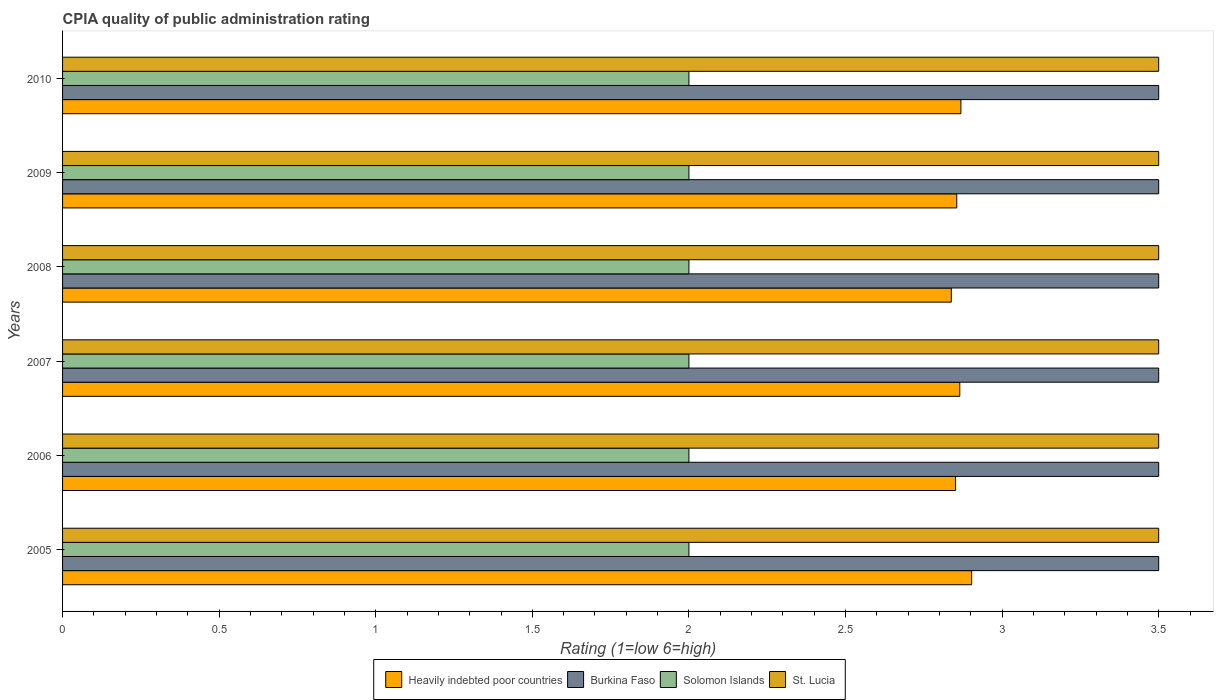How many different coloured bars are there?
Keep it short and to the point. 4. Are the number of bars on each tick of the Y-axis equal?
Keep it short and to the point. Yes. How many bars are there on the 5th tick from the bottom?
Offer a terse response. 4. Across all years, what is the maximum CPIA rating in Burkina Faso?
Provide a short and direct response. 3.5. Across all years, what is the minimum CPIA rating in Heavily indebted poor countries?
Keep it short and to the point. 2.84. What is the total CPIA rating in Heavily indebted poor countries in the graph?
Provide a short and direct response. 17.18. In the year 2010, what is the difference between the CPIA rating in Heavily indebted poor countries and CPIA rating in St. Lucia?
Your answer should be very brief. -0.63. What is the ratio of the CPIA rating in Burkina Faso in 2008 to that in 2009?
Your answer should be compact. 1. Is the CPIA rating in St. Lucia in 2007 less than that in 2010?
Ensure brevity in your answer.  No. What is the difference between the highest and the second highest CPIA rating in St. Lucia?
Keep it short and to the point. 0. What is the difference between the highest and the lowest CPIA rating in Heavily indebted poor countries?
Your answer should be compact. 0.06. Is it the case that in every year, the sum of the CPIA rating in Heavily indebted poor countries and CPIA rating in St. Lucia is greater than the sum of CPIA rating in Solomon Islands and CPIA rating in Burkina Faso?
Your answer should be compact. No. What does the 4th bar from the top in 2005 represents?
Provide a succinct answer. Heavily indebted poor countries. What does the 4th bar from the bottom in 2010 represents?
Keep it short and to the point. St. Lucia. Are all the bars in the graph horizontal?
Make the answer very short. Yes. How many years are there in the graph?
Give a very brief answer. 6. Does the graph contain grids?
Give a very brief answer. No. Where does the legend appear in the graph?
Make the answer very short. Bottom center. What is the title of the graph?
Provide a short and direct response. CPIA quality of public administration rating. What is the label or title of the X-axis?
Your answer should be very brief. Rating (1=low 6=high). What is the Rating (1=low 6=high) of Heavily indebted poor countries in 2005?
Give a very brief answer. 2.9. What is the Rating (1=low 6=high) of Burkina Faso in 2005?
Offer a very short reply. 3.5. What is the Rating (1=low 6=high) in St. Lucia in 2005?
Provide a succinct answer. 3.5. What is the Rating (1=low 6=high) of Heavily indebted poor countries in 2006?
Your answer should be very brief. 2.85. What is the Rating (1=low 6=high) in Solomon Islands in 2006?
Your answer should be compact. 2. What is the Rating (1=low 6=high) in St. Lucia in 2006?
Provide a succinct answer. 3.5. What is the Rating (1=low 6=high) of Heavily indebted poor countries in 2007?
Ensure brevity in your answer.  2.86. What is the Rating (1=low 6=high) of St. Lucia in 2007?
Make the answer very short. 3.5. What is the Rating (1=low 6=high) in Heavily indebted poor countries in 2008?
Offer a very short reply. 2.84. What is the Rating (1=low 6=high) in Solomon Islands in 2008?
Give a very brief answer. 2. What is the Rating (1=low 6=high) of Heavily indebted poor countries in 2009?
Keep it short and to the point. 2.86. What is the Rating (1=low 6=high) of Burkina Faso in 2009?
Ensure brevity in your answer.  3.5. What is the Rating (1=low 6=high) of St. Lucia in 2009?
Provide a short and direct response. 3.5. What is the Rating (1=low 6=high) of Heavily indebted poor countries in 2010?
Offer a terse response. 2.87. What is the Rating (1=low 6=high) of Burkina Faso in 2010?
Give a very brief answer. 3.5. What is the Rating (1=low 6=high) in Solomon Islands in 2010?
Give a very brief answer. 2. What is the Rating (1=low 6=high) in St. Lucia in 2010?
Make the answer very short. 3.5. Across all years, what is the maximum Rating (1=low 6=high) in Heavily indebted poor countries?
Keep it short and to the point. 2.9. Across all years, what is the maximum Rating (1=low 6=high) of Burkina Faso?
Your answer should be compact. 3.5. Across all years, what is the maximum Rating (1=low 6=high) in Solomon Islands?
Your answer should be very brief. 2. Across all years, what is the minimum Rating (1=low 6=high) of Heavily indebted poor countries?
Your answer should be compact. 2.84. Across all years, what is the minimum Rating (1=low 6=high) of Solomon Islands?
Offer a very short reply. 2. Across all years, what is the minimum Rating (1=low 6=high) of St. Lucia?
Your response must be concise. 3.5. What is the total Rating (1=low 6=high) of Heavily indebted poor countries in the graph?
Provide a succinct answer. 17.18. What is the total Rating (1=low 6=high) in Solomon Islands in the graph?
Make the answer very short. 12. What is the difference between the Rating (1=low 6=high) of Heavily indebted poor countries in 2005 and that in 2006?
Provide a succinct answer. 0.05. What is the difference between the Rating (1=low 6=high) of Burkina Faso in 2005 and that in 2006?
Offer a terse response. 0. What is the difference between the Rating (1=low 6=high) in Solomon Islands in 2005 and that in 2006?
Provide a short and direct response. 0. What is the difference between the Rating (1=low 6=high) of Heavily indebted poor countries in 2005 and that in 2007?
Keep it short and to the point. 0.04. What is the difference between the Rating (1=low 6=high) of Solomon Islands in 2005 and that in 2007?
Provide a succinct answer. 0. What is the difference between the Rating (1=low 6=high) of Heavily indebted poor countries in 2005 and that in 2008?
Keep it short and to the point. 0.06. What is the difference between the Rating (1=low 6=high) of Solomon Islands in 2005 and that in 2008?
Your answer should be very brief. 0. What is the difference between the Rating (1=low 6=high) of Heavily indebted poor countries in 2005 and that in 2009?
Offer a terse response. 0.05. What is the difference between the Rating (1=low 6=high) in Solomon Islands in 2005 and that in 2009?
Offer a terse response. 0. What is the difference between the Rating (1=low 6=high) of Heavily indebted poor countries in 2005 and that in 2010?
Ensure brevity in your answer.  0.03. What is the difference between the Rating (1=low 6=high) in Burkina Faso in 2005 and that in 2010?
Offer a very short reply. 0. What is the difference between the Rating (1=low 6=high) in St. Lucia in 2005 and that in 2010?
Your answer should be very brief. 0. What is the difference between the Rating (1=low 6=high) in Heavily indebted poor countries in 2006 and that in 2007?
Make the answer very short. -0.01. What is the difference between the Rating (1=low 6=high) of Solomon Islands in 2006 and that in 2007?
Make the answer very short. 0. What is the difference between the Rating (1=low 6=high) of Heavily indebted poor countries in 2006 and that in 2008?
Provide a short and direct response. 0.01. What is the difference between the Rating (1=low 6=high) of Solomon Islands in 2006 and that in 2008?
Offer a terse response. 0. What is the difference between the Rating (1=low 6=high) in Heavily indebted poor countries in 2006 and that in 2009?
Your response must be concise. -0. What is the difference between the Rating (1=low 6=high) of Solomon Islands in 2006 and that in 2009?
Your response must be concise. 0. What is the difference between the Rating (1=low 6=high) of St. Lucia in 2006 and that in 2009?
Give a very brief answer. 0. What is the difference between the Rating (1=low 6=high) in Heavily indebted poor countries in 2006 and that in 2010?
Your answer should be very brief. -0.02. What is the difference between the Rating (1=low 6=high) in Solomon Islands in 2006 and that in 2010?
Your answer should be very brief. 0. What is the difference between the Rating (1=low 6=high) in St. Lucia in 2006 and that in 2010?
Your answer should be very brief. 0. What is the difference between the Rating (1=low 6=high) in Heavily indebted poor countries in 2007 and that in 2008?
Ensure brevity in your answer.  0.03. What is the difference between the Rating (1=low 6=high) of Burkina Faso in 2007 and that in 2008?
Provide a short and direct response. 0. What is the difference between the Rating (1=low 6=high) in Solomon Islands in 2007 and that in 2008?
Your answer should be compact. 0. What is the difference between the Rating (1=low 6=high) in St. Lucia in 2007 and that in 2008?
Provide a short and direct response. 0. What is the difference between the Rating (1=low 6=high) in Heavily indebted poor countries in 2007 and that in 2009?
Offer a terse response. 0.01. What is the difference between the Rating (1=low 6=high) in Burkina Faso in 2007 and that in 2009?
Make the answer very short. 0. What is the difference between the Rating (1=low 6=high) of Solomon Islands in 2007 and that in 2009?
Provide a short and direct response. 0. What is the difference between the Rating (1=low 6=high) of Heavily indebted poor countries in 2007 and that in 2010?
Your response must be concise. -0. What is the difference between the Rating (1=low 6=high) in Solomon Islands in 2007 and that in 2010?
Your response must be concise. 0. What is the difference between the Rating (1=low 6=high) in St. Lucia in 2007 and that in 2010?
Provide a short and direct response. 0. What is the difference between the Rating (1=low 6=high) in Heavily indebted poor countries in 2008 and that in 2009?
Ensure brevity in your answer.  -0.02. What is the difference between the Rating (1=low 6=high) in Burkina Faso in 2008 and that in 2009?
Keep it short and to the point. 0. What is the difference between the Rating (1=low 6=high) of Solomon Islands in 2008 and that in 2009?
Ensure brevity in your answer.  0. What is the difference between the Rating (1=low 6=high) of Heavily indebted poor countries in 2008 and that in 2010?
Ensure brevity in your answer.  -0.03. What is the difference between the Rating (1=low 6=high) of Heavily indebted poor countries in 2009 and that in 2010?
Your answer should be compact. -0.01. What is the difference between the Rating (1=low 6=high) in Burkina Faso in 2009 and that in 2010?
Provide a short and direct response. 0. What is the difference between the Rating (1=low 6=high) of Solomon Islands in 2009 and that in 2010?
Make the answer very short. 0. What is the difference between the Rating (1=low 6=high) of St. Lucia in 2009 and that in 2010?
Provide a succinct answer. 0. What is the difference between the Rating (1=low 6=high) of Heavily indebted poor countries in 2005 and the Rating (1=low 6=high) of Burkina Faso in 2006?
Your response must be concise. -0.6. What is the difference between the Rating (1=low 6=high) in Heavily indebted poor countries in 2005 and the Rating (1=low 6=high) in Solomon Islands in 2006?
Offer a very short reply. 0.9. What is the difference between the Rating (1=low 6=high) in Heavily indebted poor countries in 2005 and the Rating (1=low 6=high) in St. Lucia in 2006?
Offer a very short reply. -0.6. What is the difference between the Rating (1=low 6=high) of Burkina Faso in 2005 and the Rating (1=low 6=high) of St. Lucia in 2006?
Offer a terse response. 0. What is the difference between the Rating (1=low 6=high) in Solomon Islands in 2005 and the Rating (1=low 6=high) in St. Lucia in 2006?
Keep it short and to the point. -1.5. What is the difference between the Rating (1=low 6=high) in Heavily indebted poor countries in 2005 and the Rating (1=low 6=high) in Burkina Faso in 2007?
Provide a short and direct response. -0.6. What is the difference between the Rating (1=low 6=high) of Heavily indebted poor countries in 2005 and the Rating (1=low 6=high) of Solomon Islands in 2007?
Your answer should be compact. 0.9. What is the difference between the Rating (1=low 6=high) in Heavily indebted poor countries in 2005 and the Rating (1=low 6=high) in St. Lucia in 2007?
Your answer should be very brief. -0.6. What is the difference between the Rating (1=low 6=high) in Burkina Faso in 2005 and the Rating (1=low 6=high) in Solomon Islands in 2007?
Provide a short and direct response. 1.5. What is the difference between the Rating (1=low 6=high) in Burkina Faso in 2005 and the Rating (1=low 6=high) in St. Lucia in 2007?
Make the answer very short. 0. What is the difference between the Rating (1=low 6=high) of Heavily indebted poor countries in 2005 and the Rating (1=low 6=high) of Burkina Faso in 2008?
Your answer should be very brief. -0.6. What is the difference between the Rating (1=low 6=high) in Heavily indebted poor countries in 2005 and the Rating (1=low 6=high) in Solomon Islands in 2008?
Offer a very short reply. 0.9. What is the difference between the Rating (1=low 6=high) in Heavily indebted poor countries in 2005 and the Rating (1=low 6=high) in St. Lucia in 2008?
Keep it short and to the point. -0.6. What is the difference between the Rating (1=low 6=high) of Burkina Faso in 2005 and the Rating (1=low 6=high) of St. Lucia in 2008?
Provide a short and direct response. 0. What is the difference between the Rating (1=low 6=high) in Solomon Islands in 2005 and the Rating (1=low 6=high) in St. Lucia in 2008?
Offer a very short reply. -1.5. What is the difference between the Rating (1=low 6=high) of Heavily indebted poor countries in 2005 and the Rating (1=low 6=high) of Burkina Faso in 2009?
Provide a succinct answer. -0.6. What is the difference between the Rating (1=low 6=high) in Heavily indebted poor countries in 2005 and the Rating (1=low 6=high) in Solomon Islands in 2009?
Offer a very short reply. 0.9. What is the difference between the Rating (1=low 6=high) of Heavily indebted poor countries in 2005 and the Rating (1=low 6=high) of St. Lucia in 2009?
Provide a succinct answer. -0.6. What is the difference between the Rating (1=low 6=high) in Burkina Faso in 2005 and the Rating (1=low 6=high) in Solomon Islands in 2009?
Provide a short and direct response. 1.5. What is the difference between the Rating (1=low 6=high) of Burkina Faso in 2005 and the Rating (1=low 6=high) of St. Lucia in 2009?
Give a very brief answer. 0. What is the difference between the Rating (1=low 6=high) of Heavily indebted poor countries in 2005 and the Rating (1=low 6=high) of Burkina Faso in 2010?
Provide a short and direct response. -0.6. What is the difference between the Rating (1=low 6=high) in Heavily indebted poor countries in 2005 and the Rating (1=low 6=high) in Solomon Islands in 2010?
Give a very brief answer. 0.9. What is the difference between the Rating (1=low 6=high) in Heavily indebted poor countries in 2005 and the Rating (1=low 6=high) in St. Lucia in 2010?
Your answer should be compact. -0.6. What is the difference between the Rating (1=low 6=high) of Burkina Faso in 2005 and the Rating (1=low 6=high) of Solomon Islands in 2010?
Your answer should be very brief. 1.5. What is the difference between the Rating (1=low 6=high) of Burkina Faso in 2005 and the Rating (1=low 6=high) of St. Lucia in 2010?
Provide a short and direct response. 0. What is the difference between the Rating (1=low 6=high) of Heavily indebted poor countries in 2006 and the Rating (1=low 6=high) of Burkina Faso in 2007?
Offer a very short reply. -0.65. What is the difference between the Rating (1=low 6=high) of Heavily indebted poor countries in 2006 and the Rating (1=low 6=high) of Solomon Islands in 2007?
Your answer should be compact. 0.85. What is the difference between the Rating (1=low 6=high) of Heavily indebted poor countries in 2006 and the Rating (1=low 6=high) of St. Lucia in 2007?
Your answer should be very brief. -0.65. What is the difference between the Rating (1=low 6=high) of Heavily indebted poor countries in 2006 and the Rating (1=low 6=high) of Burkina Faso in 2008?
Offer a very short reply. -0.65. What is the difference between the Rating (1=low 6=high) of Heavily indebted poor countries in 2006 and the Rating (1=low 6=high) of Solomon Islands in 2008?
Your answer should be very brief. 0.85. What is the difference between the Rating (1=low 6=high) in Heavily indebted poor countries in 2006 and the Rating (1=low 6=high) in St. Lucia in 2008?
Provide a succinct answer. -0.65. What is the difference between the Rating (1=low 6=high) of Burkina Faso in 2006 and the Rating (1=low 6=high) of Solomon Islands in 2008?
Ensure brevity in your answer.  1.5. What is the difference between the Rating (1=low 6=high) in Heavily indebted poor countries in 2006 and the Rating (1=low 6=high) in Burkina Faso in 2009?
Provide a succinct answer. -0.65. What is the difference between the Rating (1=low 6=high) in Heavily indebted poor countries in 2006 and the Rating (1=low 6=high) in Solomon Islands in 2009?
Give a very brief answer. 0.85. What is the difference between the Rating (1=low 6=high) of Heavily indebted poor countries in 2006 and the Rating (1=low 6=high) of St. Lucia in 2009?
Offer a very short reply. -0.65. What is the difference between the Rating (1=low 6=high) of Burkina Faso in 2006 and the Rating (1=low 6=high) of Solomon Islands in 2009?
Offer a terse response. 1.5. What is the difference between the Rating (1=low 6=high) in Heavily indebted poor countries in 2006 and the Rating (1=low 6=high) in Burkina Faso in 2010?
Offer a very short reply. -0.65. What is the difference between the Rating (1=low 6=high) in Heavily indebted poor countries in 2006 and the Rating (1=low 6=high) in Solomon Islands in 2010?
Ensure brevity in your answer.  0.85. What is the difference between the Rating (1=low 6=high) in Heavily indebted poor countries in 2006 and the Rating (1=low 6=high) in St. Lucia in 2010?
Give a very brief answer. -0.65. What is the difference between the Rating (1=low 6=high) of Heavily indebted poor countries in 2007 and the Rating (1=low 6=high) of Burkina Faso in 2008?
Your response must be concise. -0.64. What is the difference between the Rating (1=low 6=high) of Heavily indebted poor countries in 2007 and the Rating (1=low 6=high) of Solomon Islands in 2008?
Your answer should be very brief. 0.86. What is the difference between the Rating (1=low 6=high) of Heavily indebted poor countries in 2007 and the Rating (1=low 6=high) of St. Lucia in 2008?
Ensure brevity in your answer.  -0.64. What is the difference between the Rating (1=low 6=high) of Burkina Faso in 2007 and the Rating (1=low 6=high) of Solomon Islands in 2008?
Offer a terse response. 1.5. What is the difference between the Rating (1=low 6=high) in Heavily indebted poor countries in 2007 and the Rating (1=low 6=high) in Burkina Faso in 2009?
Your answer should be very brief. -0.64. What is the difference between the Rating (1=low 6=high) in Heavily indebted poor countries in 2007 and the Rating (1=low 6=high) in Solomon Islands in 2009?
Your response must be concise. 0.86. What is the difference between the Rating (1=low 6=high) of Heavily indebted poor countries in 2007 and the Rating (1=low 6=high) of St. Lucia in 2009?
Make the answer very short. -0.64. What is the difference between the Rating (1=low 6=high) of Burkina Faso in 2007 and the Rating (1=low 6=high) of Solomon Islands in 2009?
Your answer should be compact. 1.5. What is the difference between the Rating (1=low 6=high) of Burkina Faso in 2007 and the Rating (1=low 6=high) of St. Lucia in 2009?
Offer a terse response. 0. What is the difference between the Rating (1=low 6=high) of Solomon Islands in 2007 and the Rating (1=low 6=high) of St. Lucia in 2009?
Your answer should be very brief. -1.5. What is the difference between the Rating (1=low 6=high) of Heavily indebted poor countries in 2007 and the Rating (1=low 6=high) of Burkina Faso in 2010?
Keep it short and to the point. -0.64. What is the difference between the Rating (1=low 6=high) of Heavily indebted poor countries in 2007 and the Rating (1=low 6=high) of Solomon Islands in 2010?
Your answer should be compact. 0.86. What is the difference between the Rating (1=low 6=high) in Heavily indebted poor countries in 2007 and the Rating (1=low 6=high) in St. Lucia in 2010?
Give a very brief answer. -0.64. What is the difference between the Rating (1=low 6=high) of Burkina Faso in 2007 and the Rating (1=low 6=high) of Solomon Islands in 2010?
Provide a succinct answer. 1.5. What is the difference between the Rating (1=low 6=high) of Burkina Faso in 2007 and the Rating (1=low 6=high) of St. Lucia in 2010?
Make the answer very short. 0. What is the difference between the Rating (1=low 6=high) in Solomon Islands in 2007 and the Rating (1=low 6=high) in St. Lucia in 2010?
Make the answer very short. -1.5. What is the difference between the Rating (1=low 6=high) in Heavily indebted poor countries in 2008 and the Rating (1=low 6=high) in Burkina Faso in 2009?
Offer a very short reply. -0.66. What is the difference between the Rating (1=low 6=high) of Heavily indebted poor countries in 2008 and the Rating (1=low 6=high) of Solomon Islands in 2009?
Offer a terse response. 0.84. What is the difference between the Rating (1=low 6=high) in Heavily indebted poor countries in 2008 and the Rating (1=low 6=high) in St. Lucia in 2009?
Your answer should be compact. -0.66. What is the difference between the Rating (1=low 6=high) of Burkina Faso in 2008 and the Rating (1=low 6=high) of St. Lucia in 2009?
Offer a terse response. 0. What is the difference between the Rating (1=low 6=high) of Solomon Islands in 2008 and the Rating (1=low 6=high) of St. Lucia in 2009?
Your answer should be very brief. -1.5. What is the difference between the Rating (1=low 6=high) in Heavily indebted poor countries in 2008 and the Rating (1=low 6=high) in Burkina Faso in 2010?
Your answer should be very brief. -0.66. What is the difference between the Rating (1=low 6=high) of Heavily indebted poor countries in 2008 and the Rating (1=low 6=high) of Solomon Islands in 2010?
Provide a succinct answer. 0.84. What is the difference between the Rating (1=low 6=high) of Heavily indebted poor countries in 2008 and the Rating (1=low 6=high) of St. Lucia in 2010?
Keep it short and to the point. -0.66. What is the difference between the Rating (1=low 6=high) in Burkina Faso in 2008 and the Rating (1=low 6=high) in Solomon Islands in 2010?
Your answer should be compact. 1.5. What is the difference between the Rating (1=low 6=high) of Burkina Faso in 2008 and the Rating (1=low 6=high) of St. Lucia in 2010?
Your answer should be compact. 0. What is the difference between the Rating (1=low 6=high) of Solomon Islands in 2008 and the Rating (1=low 6=high) of St. Lucia in 2010?
Provide a short and direct response. -1.5. What is the difference between the Rating (1=low 6=high) in Heavily indebted poor countries in 2009 and the Rating (1=low 6=high) in Burkina Faso in 2010?
Provide a short and direct response. -0.64. What is the difference between the Rating (1=low 6=high) in Heavily indebted poor countries in 2009 and the Rating (1=low 6=high) in Solomon Islands in 2010?
Give a very brief answer. 0.86. What is the difference between the Rating (1=low 6=high) in Heavily indebted poor countries in 2009 and the Rating (1=low 6=high) in St. Lucia in 2010?
Ensure brevity in your answer.  -0.64. What is the difference between the Rating (1=low 6=high) in Burkina Faso in 2009 and the Rating (1=low 6=high) in Solomon Islands in 2010?
Keep it short and to the point. 1.5. What is the difference between the Rating (1=low 6=high) of Solomon Islands in 2009 and the Rating (1=low 6=high) of St. Lucia in 2010?
Make the answer very short. -1.5. What is the average Rating (1=low 6=high) of Heavily indebted poor countries per year?
Your answer should be compact. 2.86. What is the average Rating (1=low 6=high) in Solomon Islands per year?
Keep it short and to the point. 2. What is the average Rating (1=low 6=high) in St. Lucia per year?
Your response must be concise. 3.5. In the year 2005, what is the difference between the Rating (1=low 6=high) in Heavily indebted poor countries and Rating (1=low 6=high) in Burkina Faso?
Keep it short and to the point. -0.6. In the year 2005, what is the difference between the Rating (1=low 6=high) in Heavily indebted poor countries and Rating (1=low 6=high) in Solomon Islands?
Make the answer very short. 0.9. In the year 2005, what is the difference between the Rating (1=low 6=high) of Heavily indebted poor countries and Rating (1=low 6=high) of St. Lucia?
Offer a very short reply. -0.6. In the year 2005, what is the difference between the Rating (1=low 6=high) of Burkina Faso and Rating (1=low 6=high) of St. Lucia?
Your answer should be compact. 0. In the year 2006, what is the difference between the Rating (1=low 6=high) in Heavily indebted poor countries and Rating (1=low 6=high) in Burkina Faso?
Offer a terse response. -0.65. In the year 2006, what is the difference between the Rating (1=low 6=high) in Heavily indebted poor countries and Rating (1=low 6=high) in Solomon Islands?
Provide a short and direct response. 0.85. In the year 2006, what is the difference between the Rating (1=low 6=high) of Heavily indebted poor countries and Rating (1=low 6=high) of St. Lucia?
Offer a very short reply. -0.65. In the year 2006, what is the difference between the Rating (1=low 6=high) in Burkina Faso and Rating (1=low 6=high) in St. Lucia?
Make the answer very short. 0. In the year 2007, what is the difference between the Rating (1=low 6=high) of Heavily indebted poor countries and Rating (1=low 6=high) of Burkina Faso?
Offer a very short reply. -0.64. In the year 2007, what is the difference between the Rating (1=low 6=high) of Heavily indebted poor countries and Rating (1=low 6=high) of Solomon Islands?
Your response must be concise. 0.86. In the year 2007, what is the difference between the Rating (1=low 6=high) in Heavily indebted poor countries and Rating (1=low 6=high) in St. Lucia?
Offer a terse response. -0.64. In the year 2007, what is the difference between the Rating (1=low 6=high) in Burkina Faso and Rating (1=low 6=high) in Solomon Islands?
Give a very brief answer. 1.5. In the year 2007, what is the difference between the Rating (1=low 6=high) in Burkina Faso and Rating (1=low 6=high) in St. Lucia?
Offer a terse response. 0. In the year 2007, what is the difference between the Rating (1=low 6=high) in Solomon Islands and Rating (1=low 6=high) in St. Lucia?
Ensure brevity in your answer.  -1.5. In the year 2008, what is the difference between the Rating (1=low 6=high) of Heavily indebted poor countries and Rating (1=low 6=high) of Burkina Faso?
Offer a terse response. -0.66. In the year 2008, what is the difference between the Rating (1=low 6=high) in Heavily indebted poor countries and Rating (1=low 6=high) in Solomon Islands?
Your answer should be compact. 0.84. In the year 2008, what is the difference between the Rating (1=low 6=high) in Heavily indebted poor countries and Rating (1=low 6=high) in St. Lucia?
Ensure brevity in your answer.  -0.66. In the year 2008, what is the difference between the Rating (1=low 6=high) in Burkina Faso and Rating (1=low 6=high) in Solomon Islands?
Your response must be concise. 1.5. In the year 2008, what is the difference between the Rating (1=low 6=high) of Burkina Faso and Rating (1=low 6=high) of St. Lucia?
Provide a short and direct response. 0. In the year 2009, what is the difference between the Rating (1=low 6=high) of Heavily indebted poor countries and Rating (1=low 6=high) of Burkina Faso?
Your response must be concise. -0.64. In the year 2009, what is the difference between the Rating (1=low 6=high) in Heavily indebted poor countries and Rating (1=low 6=high) in Solomon Islands?
Offer a very short reply. 0.86. In the year 2009, what is the difference between the Rating (1=low 6=high) in Heavily indebted poor countries and Rating (1=low 6=high) in St. Lucia?
Offer a very short reply. -0.64. In the year 2009, what is the difference between the Rating (1=low 6=high) of Burkina Faso and Rating (1=low 6=high) of Solomon Islands?
Your answer should be very brief. 1.5. In the year 2009, what is the difference between the Rating (1=low 6=high) in Solomon Islands and Rating (1=low 6=high) in St. Lucia?
Provide a succinct answer. -1.5. In the year 2010, what is the difference between the Rating (1=low 6=high) in Heavily indebted poor countries and Rating (1=low 6=high) in Burkina Faso?
Provide a short and direct response. -0.63. In the year 2010, what is the difference between the Rating (1=low 6=high) in Heavily indebted poor countries and Rating (1=low 6=high) in Solomon Islands?
Make the answer very short. 0.87. In the year 2010, what is the difference between the Rating (1=low 6=high) of Heavily indebted poor countries and Rating (1=low 6=high) of St. Lucia?
Your answer should be very brief. -0.63. In the year 2010, what is the difference between the Rating (1=low 6=high) of Burkina Faso and Rating (1=low 6=high) of Solomon Islands?
Provide a succinct answer. 1.5. In the year 2010, what is the difference between the Rating (1=low 6=high) in Solomon Islands and Rating (1=low 6=high) in St. Lucia?
Give a very brief answer. -1.5. What is the ratio of the Rating (1=low 6=high) in Heavily indebted poor countries in 2005 to that in 2006?
Provide a succinct answer. 1.02. What is the ratio of the Rating (1=low 6=high) of Burkina Faso in 2005 to that in 2006?
Make the answer very short. 1. What is the ratio of the Rating (1=low 6=high) in Solomon Islands in 2005 to that in 2006?
Provide a succinct answer. 1. What is the ratio of the Rating (1=low 6=high) in St. Lucia in 2005 to that in 2006?
Provide a short and direct response. 1. What is the ratio of the Rating (1=low 6=high) of Heavily indebted poor countries in 2005 to that in 2007?
Ensure brevity in your answer.  1.01. What is the ratio of the Rating (1=low 6=high) of Solomon Islands in 2005 to that in 2007?
Your answer should be compact. 1. What is the ratio of the Rating (1=low 6=high) in St. Lucia in 2005 to that in 2007?
Provide a short and direct response. 1. What is the ratio of the Rating (1=low 6=high) in Heavily indebted poor countries in 2005 to that in 2008?
Provide a short and direct response. 1.02. What is the ratio of the Rating (1=low 6=high) of Burkina Faso in 2005 to that in 2008?
Provide a short and direct response. 1. What is the ratio of the Rating (1=low 6=high) of St. Lucia in 2005 to that in 2008?
Make the answer very short. 1. What is the ratio of the Rating (1=low 6=high) of Heavily indebted poor countries in 2005 to that in 2009?
Ensure brevity in your answer.  1.02. What is the ratio of the Rating (1=low 6=high) of Solomon Islands in 2005 to that in 2009?
Keep it short and to the point. 1. What is the ratio of the Rating (1=low 6=high) of Heavily indebted poor countries in 2005 to that in 2010?
Ensure brevity in your answer.  1.01. What is the ratio of the Rating (1=low 6=high) in Solomon Islands in 2005 to that in 2010?
Your answer should be compact. 1. What is the ratio of the Rating (1=low 6=high) of St. Lucia in 2005 to that in 2010?
Give a very brief answer. 1. What is the ratio of the Rating (1=low 6=high) in Solomon Islands in 2006 to that in 2007?
Give a very brief answer. 1. What is the ratio of the Rating (1=low 6=high) of Burkina Faso in 2006 to that in 2008?
Make the answer very short. 1. What is the ratio of the Rating (1=low 6=high) of St. Lucia in 2006 to that in 2008?
Your response must be concise. 1. What is the ratio of the Rating (1=low 6=high) of Burkina Faso in 2006 to that in 2009?
Keep it short and to the point. 1. What is the ratio of the Rating (1=low 6=high) of St. Lucia in 2006 to that in 2010?
Your answer should be very brief. 1. What is the ratio of the Rating (1=low 6=high) in Heavily indebted poor countries in 2007 to that in 2008?
Your answer should be very brief. 1.01. What is the ratio of the Rating (1=low 6=high) in St. Lucia in 2007 to that in 2008?
Your response must be concise. 1. What is the ratio of the Rating (1=low 6=high) of St. Lucia in 2007 to that in 2009?
Your answer should be compact. 1. What is the ratio of the Rating (1=low 6=high) in Burkina Faso in 2007 to that in 2010?
Ensure brevity in your answer.  1. What is the ratio of the Rating (1=low 6=high) of St. Lucia in 2008 to that in 2009?
Provide a succinct answer. 1. What is the ratio of the Rating (1=low 6=high) in Heavily indebted poor countries in 2008 to that in 2010?
Provide a succinct answer. 0.99. What is the ratio of the Rating (1=low 6=high) of Burkina Faso in 2009 to that in 2010?
Keep it short and to the point. 1. What is the ratio of the Rating (1=low 6=high) in Solomon Islands in 2009 to that in 2010?
Your answer should be compact. 1. What is the ratio of the Rating (1=low 6=high) in St. Lucia in 2009 to that in 2010?
Your answer should be very brief. 1. What is the difference between the highest and the second highest Rating (1=low 6=high) in Heavily indebted poor countries?
Offer a terse response. 0.03. What is the difference between the highest and the second highest Rating (1=low 6=high) of Solomon Islands?
Offer a terse response. 0. What is the difference between the highest and the lowest Rating (1=low 6=high) of Heavily indebted poor countries?
Ensure brevity in your answer.  0.06. What is the difference between the highest and the lowest Rating (1=low 6=high) of Burkina Faso?
Ensure brevity in your answer.  0. What is the difference between the highest and the lowest Rating (1=low 6=high) of St. Lucia?
Offer a terse response. 0. 